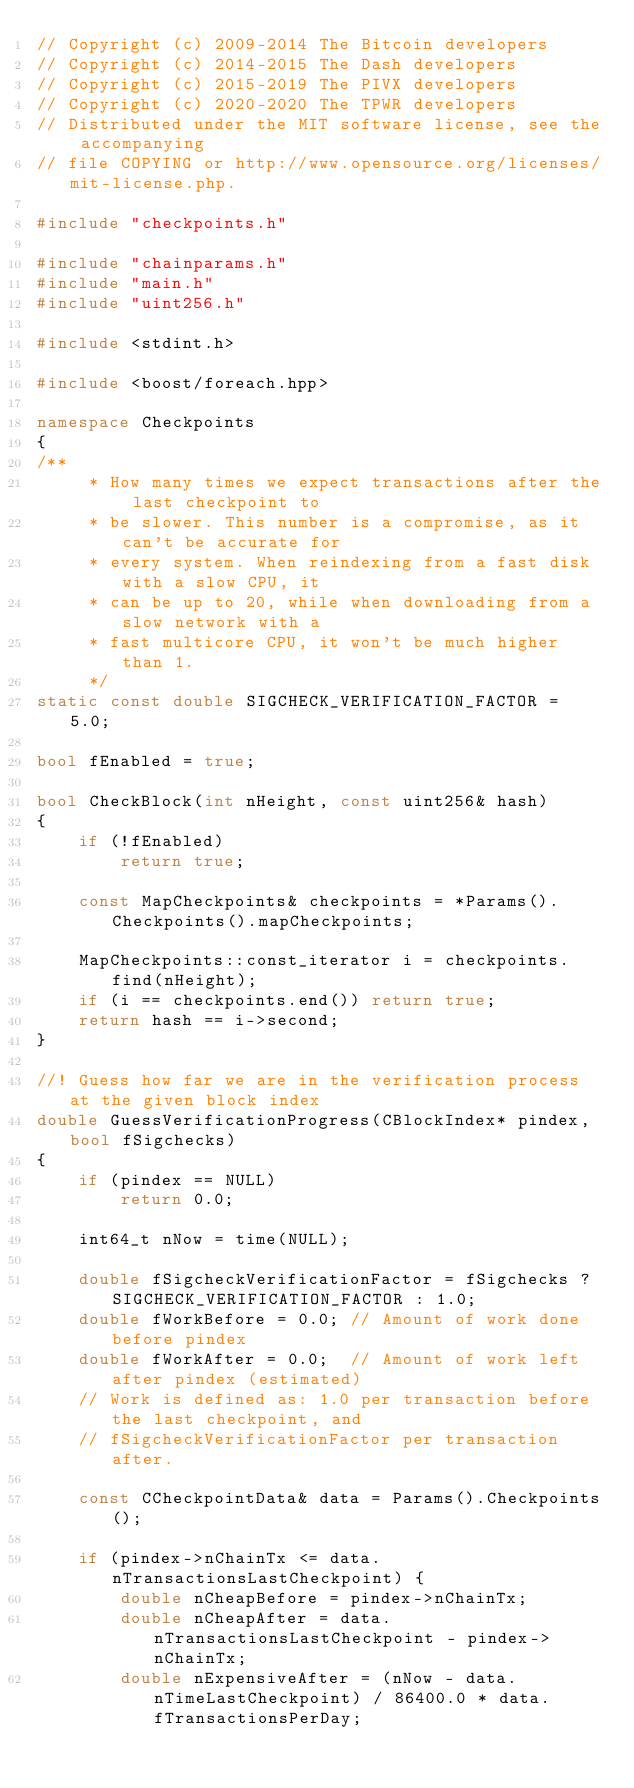Convert code to text. <code><loc_0><loc_0><loc_500><loc_500><_C++_>// Copyright (c) 2009-2014 The Bitcoin developers
// Copyright (c) 2014-2015 The Dash developers
// Copyright (c) 2015-2019 The PIVX developers
// Copyright (c) 2020-2020 The TPWR developers
// Distributed under the MIT software license, see the accompanying
// file COPYING or http://www.opensource.org/licenses/mit-license.php.

#include "checkpoints.h"

#include "chainparams.h"
#include "main.h"
#include "uint256.h"

#include <stdint.h>

#include <boost/foreach.hpp>

namespace Checkpoints
{
/**
     * How many times we expect transactions after the last checkpoint to
     * be slower. This number is a compromise, as it can't be accurate for
     * every system. When reindexing from a fast disk with a slow CPU, it
     * can be up to 20, while when downloading from a slow network with a
     * fast multicore CPU, it won't be much higher than 1.
     */
static const double SIGCHECK_VERIFICATION_FACTOR = 5.0;

bool fEnabled = true;

bool CheckBlock(int nHeight, const uint256& hash)
{
    if (!fEnabled)
        return true;

    const MapCheckpoints& checkpoints = *Params().Checkpoints().mapCheckpoints;

    MapCheckpoints::const_iterator i = checkpoints.find(nHeight);
    if (i == checkpoints.end()) return true;
    return hash == i->second;
}

//! Guess how far we are in the verification process at the given block index
double GuessVerificationProgress(CBlockIndex* pindex, bool fSigchecks)
{
    if (pindex == NULL)
        return 0.0;

    int64_t nNow = time(NULL);

    double fSigcheckVerificationFactor = fSigchecks ? SIGCHECK_VERIFICATION_FACTOR : 1.0;
    double fWorkBefore = 0.0; // Amount of work done before pindex
    double fWorkAfter = 0.0;  // Amount of work left after pindex (estimated)
    // Work is defined as: 1.0 per transaction before the last checkpoint, and
    // fSigcheckVerificationFactor per transaction after.

    const CCheckpointData& data = Params().Checkpoints();

    if (pindex->nChainTx <= data.nTransactionsLastCheckpoint) {
        double nCheapBefore = pindex->nChainTx;
        double nCheapAfter = data.nTransactionsLastCheckpoint - pindex->nChainTx;
        double nExpensiveAfter = (nNow - data.nTimeLastCheckpoint) / 86400.0 * data.fTransactionsPerDay;</code> 